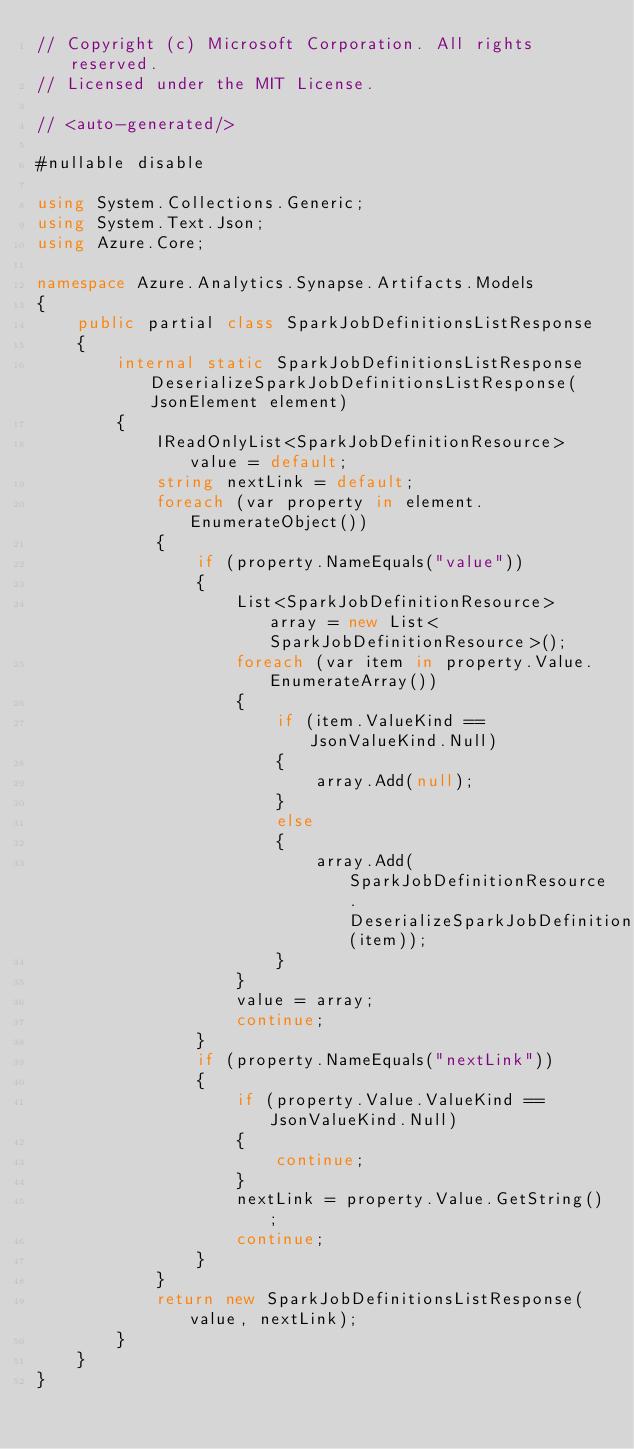<code> <loc_0><loc_0><loc_500><loc_500><_C#_>// Copyright (c) Microsoft Corporation. All rights reserved.
// Licensed under the MIT License.

// <auto-generated/>

#nullable disable

using System.Collections.Generic;
using System.Text.Json;
using Azure.Core;

namespace Azure.Analytics.Synapse.Artifacts.Models
{
    public partial class SparkJobDefinitionsListResponse
    {
        internal static SparkJobDefinitionsListResponse DeserializeSparkJobDefinitionsListResponse(JsonElement element)
        {
            IReadOnlyList<SparkJobDefinitionResource> value = default;
            string nextLink = default;
            foreach (var property in element.EnumerateObject())
            {
                if (property.NameEquals("value"))
                {
                    List<SparkJobDefinitionResource> array = new List<SparkJobDefinitionResource>();
                    foreach (var item in property.Value.EnumerateArray())
                    {
                        if (item.ValueKind == JsonValueKind.Null)
                        {
                            array.Add(null);
                        }
                        else
                        {
                            array.Add(SparkJobDefinitionResource.DeserializeSparkJobDefinitionResource(item));
                        }
                    }
                    value = array;
                    continue;
                }
                if (property.NameEquals("nextLink"))
                {
                    if (property.Value.ValueKind == JsonValueKind.Null)
                    {
                        continue;
                    }
                    nextLink = property.Value.GetString();
                    continue;
                }
            }
            return new SparkJobDefinitionsListResponse(value, nextLink);
        }
    }
}
</code> 